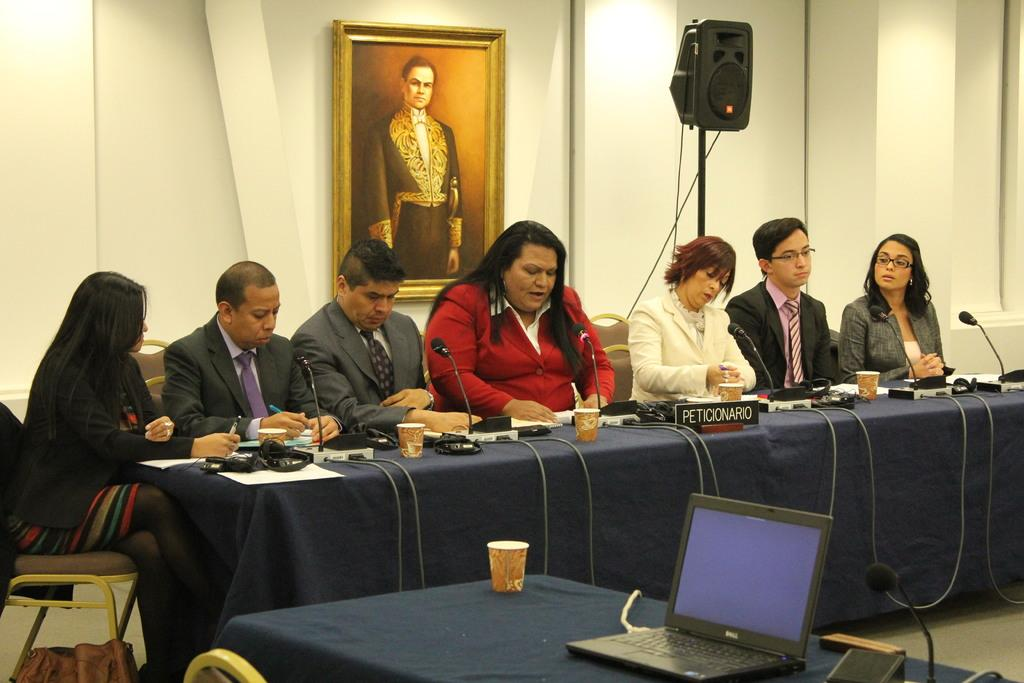Provide a one-sentence caption for the provided image. People sitting behind a desk with a sign that says "PETICIONARIO". 